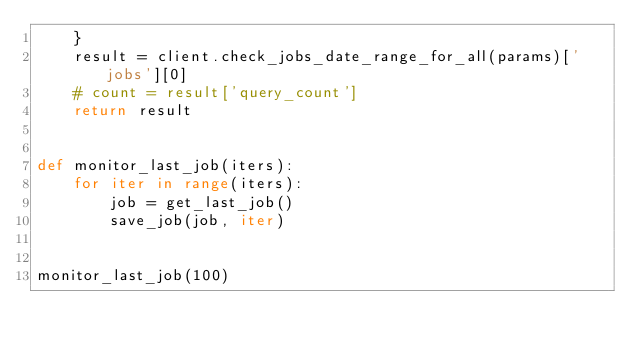<code> <loc_0><loc_0><loc_500><loc_500><_Python_>    }
    result = client.check_jobs_date_range_for_all(params)['jobs'][0]
    # count = result['query_count']
    return result


def monitor_last_job(iters):
    for iter in range(iters):
        job = get_last_job()
        save_job(job, iter)


monitor_last_job(100)
</code> 